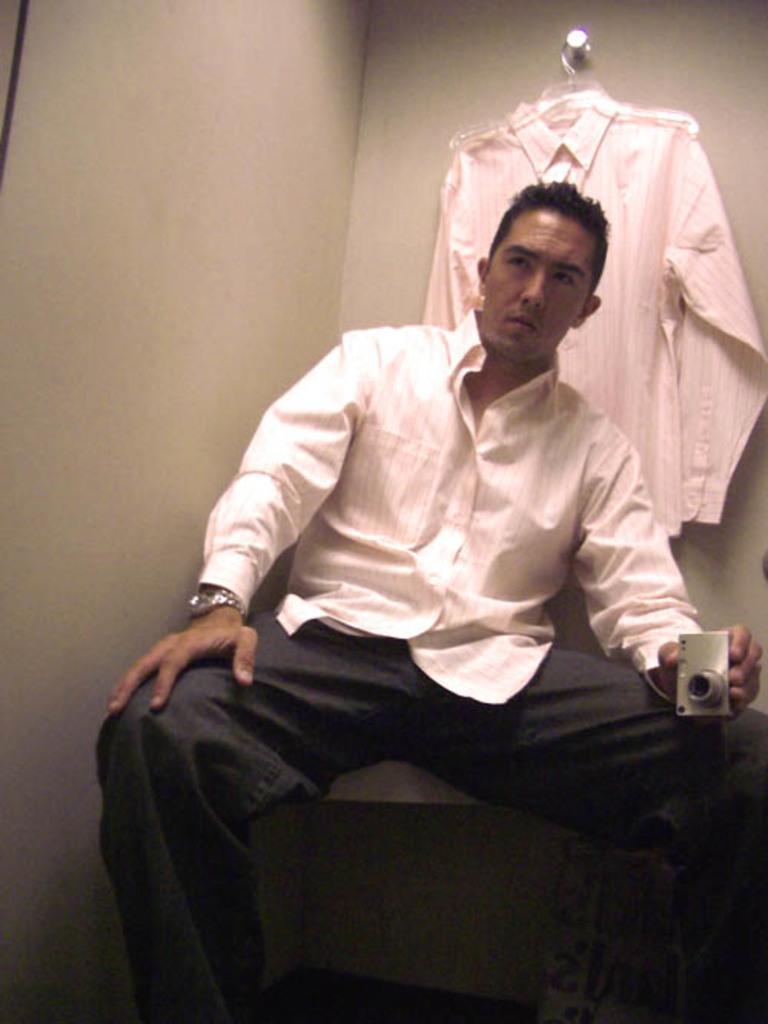How would you summarize this image in a sentence or two? In the image there is a man sitting and holding a camera, behind him there is a shirt hanged to a rod and in the background there is a wall. 